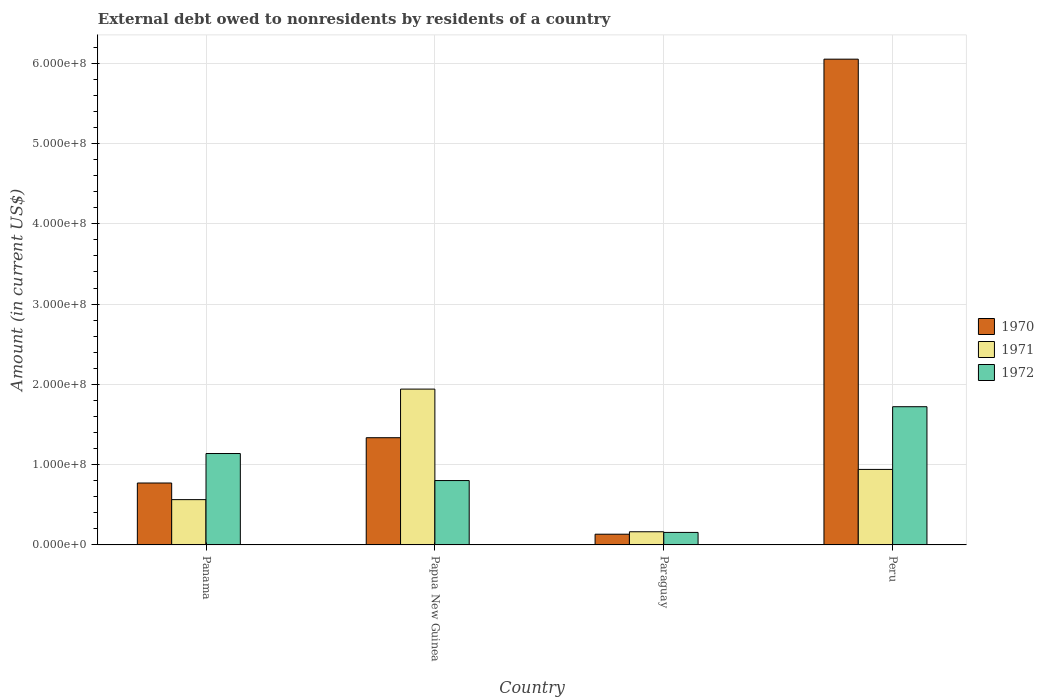How many different coloured bars are there?
Ensure brevity in your answer.  3. Are the number of bars on each tick of the X-axis equal?
Ensure brevity in your answer.  Yes. What is the label of the 4th group of bars from the left?
Make the answer very short. Peru. What is the external debt owed by residents in 1970 in Panama?
Ensure brevity in your answer.  7.71e+07. Across all countries, what is the maximum external debt owed by residents in 1972?
Offer a very short reply. 1.72e+08. Across all countries, what is the minimum external debt owed by residents in 1972?
Offer a terse response. 1.56e+07. In which country was the external debt owed by residents in 1971 minimum?
Your answer should be compact. Paraguay. What is the total external debt owed by residents in 1970 in the graph?
Ensure brevity in your answer.  8.29e+08. What is the difference between the external debt owed by residents in 1970 in Paraguay and that in Peru?
Offer a very short reply. -5.92e+08. What is the difference between the external debt owed by residents in 1970 in Papua New Guinea and the external debt owed by residents in 1971 in Peru?
Give a very brief answer. 3.95e+07. What is the average external debt owed by residents in 1972 per country?
Make the answer very short. 9.54e+07. What is the difference between the external debt owed by residents of/in 1971 and external debt owed by residents of/in 1970 in Papua New Guinea?
Keep it short and to the point. 6.05e+07. In how many countries, is the external debt owed by residents in 1972 greater than 480000000 US$?
Your response must be concise. 0. What is the ratio of the external debt owed by residents in 1971 in Papua New Guinea to that in Peru?
Your response must be concise. 2.06. Is the external debt owed by residents in 1972 in Panama less than that in Papua New Guinea?
Offer a terse response. No. What is the difference between the highest and the second highest external debt owed by residents in 1970?
Provide a short and direct response. 4.71e+08. What is the difference between the highest and the lowest external debt owed by residents in 1970?
Ensure brevity in your answer.  5.92e+08. What does the 3rd bar from the left in Paraguay represents?
Provide a short and direct response. 1972. What does the 2nd bar from the right in Paraguay represents?
Offer a terse response. 1971. How many bars are there?
Your answer should be compact. 12. Are all the bars in the graph horizontal?
Ensure brevity in your answer.  No. How many legend labels are there?
Make the answer very short. 3. What is the title of the graph?
Offer a terse response. External debt owed to nonresidents by residents of a country. Does "1965" appear as one of the legend labels in the graph?
Give a very brief answer. No. What is the label or title of the X-axis?
Keep it short and to the point. Country. What is the Amount (in current US$) of 1970 in Panama?
Provide a short and direct response. 7.71e+07. What is the Amount (in current US$) of 1971 in Panama?
Make the answer very short. 5.64e+07. What is the Amount (in current US$) in 1972 in Panama?
Give a very brief answer. 1.14e+08. What is the Amount (in current US$) in 1970 in Papua New Guinea?
Ensure brevity in your answer.  1.34e+08. What is the Amount (in current US$) of 1971 in Papua New Guinea?
Offer a terse response. 1.94e+08. What is the Amount (in current US$) of 1972 in Papua New Guinea?
Offer a terse response. 8.02e+07. What is the Amount (in current US$) in 1970 in Paraguay?
Your response must be concise. 1.34e+07. What is the Amount (in current US$) of 1971 in Paraguay?
Your answer should be very brief. 1.64e+07. What is the Amount (in current US$) of 1972 in Paraguay?
Offer a very short reply. 1.56e+07. What is the Amount (in current US$) of 1970 in Peru?
Your answer should be compact. 6.05e+08. What is the Amount (in current US$) of 1971 in Peru?
Keep it short and to the point. 9.41e+07. What is the Amount (in current US$) in 1972 in Peru?
Offer a terse response. 1.72e+08. Across all countries, what is the maximum Amount (in current US$) in 1970?
Offer a very short reply. 6.05e+08. Across all countries, what is the maximum Amount (in current US$) of 1971?
Your answer should be compact. 1.94e+08. Across all countries, what is the maximum Amount (in current US$) in 1972?
Offer a very short reply. 1.72e+08. Across all countries, what is the minimum Amount (in current US$) in 1970?
Keep it short and to the point. 1.34e+07. Across all countries, what is the minimum Amount (in current US$) in 1971?
Keep it short and to the point. 1.64e+07. Across all countries, what is the minimum Amount (in current US$) in 1972?
Make the answer very short. 1.56e+07. What is the total Amount (in current US$) in 1970 in the graph?
Give a very brief answer. 8.29e+08. What is the total Amount (in current US$) of 1971 in the graph?
Your answer should be very brief. 3.61e+08. What is the total Amount (in current US$) of 1972 in the graph?
Offer a terse response. 3.82e+08. What is the difference between the Amount (in current US$) of 1970 in Panama and that in Papua New Guinea?
Your answer should be very brief. -5.64e+07. What is the difference between the Amount (in current US$) of 1971 in Panama and that in Papua New Guinea?
Offer a very short reply. -1.38e+08. What is the difference between the Amount (in current US$) of 1972 in Panama and that in Papua New Guinea?
Make the answer very short. 3.37e+07. What is the difference between the Amount (in current US$) in 1970 in Panama and that in Paraguay?
Provide a succinct answer. 6.38e+07. What is the difference between the Amount (in current US$) of 1971 in Panama and that in Paraguay?
Your answer should be very brief. 4.00e+07. What is the difference between the Amount (in current US$) of 1972 in Panama and that in Paraguay?
Your answer should be very brief. 9.83e+07. What is the difference between the Amount (in current US$) in 1970 in Panama and that in Peru?
Provide a succinct answer. -5.28e+08. What is the difference between the Amount (in current US$) of 1971 in Panama and that in Peru?
Give a very brief answer. -3.76e+07. What is the difference between the Amount (in current US$) of 1972 in Panama and that in Peru?
Offer a very short reply. -5.83e+07. What is the difference between the Amount (in current US$) of 1970 in Papua New Guinea and that in Paraguay?
Your answer should be compact. 1.20e+08. What is the difference between the Amount (in current US$) in 1971 in Papua New Guinea and that in Paraguay?
Ensure brevity in your answer.  1.78e+08. What is the difference between the Amount (in current US$) in 1972 in Papua New Guinea and that in Paraguay?
Make the answer very short. 6.46e+07. What is the difference between the Amount (in current US$) of 1970 in Papua New Guinea and that in Peru?
Provide a succinct answer. -4.71e+08. What is the difference between the Amount (in current US$) of 1971 in Papua New Guinea and that in Peru?
Make the answer very short. 1.00e+08. What is the difference between the Amount (in current US$) of 1972 in Papua New Guinea and that in Peru?
Give a very brief answer. -9.20e+07. What is the difference between the Amount (in current US$) in 1970 in Paraguay and that in Peru?
Offer a very short reply. -5.92e+08. What is the difference between the Amount (in current US$) in 1971 in Paraguay and that in Peru?
Your answer should be compact. -7.76e+07. What is the difference between the Amount (in current US$) in 1972 in Paraguay and that in Peru?
Provide a short and direct response. -1.57e+08. What is the difference between the Amount (in current US$) in 1970 in Panama and the Amount (in current US$) in 1971 in Papua New Guinea?
Offer a terse response. -1.17e+08. What is the difference between the Amount (in current US$) in 1970 in Panama and the Amount (in current US$) in 1972 in Papua New Guinea?
Your answer should be compact. -3.07e+06. What is the difference between the Amount (in current US$) in 1971 in Panama and the Amount (in current US$) in 1972 in Papua New Guinea?
Ensure brevity in your answer.  -2.38e+07. What is the difference between the Amount (in current US$) of 1970 in Panama and the Amount (in current US$) of 1971 in Paraguay?
Provide a short and direct response. 6.07e+07. What is the difference between the Amount (in current US$) of 1970 in Panama and the Amount (in current US$) of 1972 in Paraguay?
Keep it short and to the point. 6.15e+07. What is the difference between the Amount (in current US$) of 1971 in Panama and the Amount (in current US$) of 1972 in Paraguay?
Provide a short and direct response. 4.08e+07. What is the difference between the Amount (in current US$) in 1970 in Panama and the Amount (in current US$) in 1971 in Peru?
Offer a terse response. -1.69e+07. What is the difference between the Amount (in current US$) of 1970 in Panama and the Amount (in current US$) of 1972 in Peru?
Give a very brief answer. -9.50e+07. What is the difference between the Amount (in current US$) of 1971 in Panama and the Amount (in current US$) of 1972 in Peru?
Your answer should be compact. -1.16e+08. What is the difference between the Amount (in current US$) of 1970 in Papua New Guinea and the Amount (in current US$) of 1971 in Paraguay?
Give a very brief answer. 1.17e+08. What is the difference between the Amount (in current US$) in 1970 in Papua New Guinea and the Amount (in current US$) in 1972 in Paraguay?
Provide a short and direct response. 1.18e+08. What is the difference between the Amount (in current US$) in 1971 in Papua New Guinea and the Amount (in current US$) in 1972 in Paraguay?
Your response must be concise. 1.78e+08. What is the difference between the Amount (in current US$) in 1970 in Papua New Guinea and the Amount (in current US$) in 1971 in Peru?
Your response must be concise. 3.95e+07. What is the difference between the Amount (in current US$) in 1970 in Papua New Guinea and the Amount (in current US$) in 1972 in Peru?
Keep it short and to the point. -3.86e+07. What is the difference between the Amount (in current US$) in 1971 in Papua New Guinea and the Amount (in current US$) in 1972 in Peru?
Provide a succinct answer. 2.19e+07. What is the difference between the Amount (in current US$) of 1970 in Paraguay and the Amount (in current US$) of 1971 in Peru?
Your answer should be compact. -8.07e+07. What is the difference between the Amount (in current US$) of 1970 in Paraguay and the Amount (in current US$) of 1972 in Peru?
Keep it short and to the point. -1.59e+08. What is the difference between the Amount (in current US$) in 1971 in Paraguay and the Amount (in current US$) in 1972 in Peru?
Ensure brevity in your answer.  -1.56e+08. What is the average Amount (in current US$) of 1970 per country?
Provide a short and direct response. 2.07e+08. What is the average Amount (in current US$) in 1971 per country?
Ensure brevity in your answer.  9.02e+07. What is the average Amount (in current US$) of 1972 per country?
Make the answer very short. 9.54e+07. What is the difference between the Amount (in current US$) in 1970 and Amount (in current US$) in 1971 in Panama?
Keep it short and to the point. 2.07e+07. What is the difference between the Amount (in current US$) in 1970 and Amount (in current US$) in 1972 in Panama?
Provide a succinct answer. -3.67e+07. What is the difference between the Amount (in current US$) in 1971 and Amount (in current US$) in 1972 in Panama?
Ensure brevity in your answer.  -5.74e+07. What is the difference between the Amount (in current US$) of 1970 and Amount (in current US$) of 1971 in Papua New Guinea?
Give a very brief answer. -6.05e+07. What is the difference between the Amount (in current US$) in 1970 and Amount (in current US$) in 1972 in Papua New Guinea?
Keep it short and to the point. 5.34e+07. What is the difference between the Amount (in current US$) in 1971 and Amount (in current US$) in 1972 in Papua New Guinea?
Offer a very short reply. 1.14e+08. What is the difference between the Amount (in current US$) of 1970 and Amount (in current US$) of 1971 in Paraguay?
Offer a terse response. -3.05e+06. What is the difference between the Amount (in current US$) of 1970 and Amount (in current US$) of 1972 in Paraguay?
Provide a short and direct response. -2.23e+06. What is the difference between the Amount (in current US$) in 1971 and Amount (in current US$) in 1972 in Paraguay?
Your answer should be very brief. 8.15e+05. What is the difference between the Amount (in current US$) of 1970 and Amount (in current US$) of 1971 in Peru?
Give a very brief answer. 5.11e+08. What is the difference between the Amount (in current US$) of 1970 and Amount (in current US$) of 1972 in Peru?
Offer a terse response. 4.33e+08. What is the difference between the Amount (in current US$) in 1971 and Amount (in current US$) in 1972 in Peru?
Your answer should be compact. -7.81e+07. What is the ratio of the Amount (in current US$) in 1970 in Panama to that in Papua New Guinea?
Your answer should be very brief. 0.58. What is the ratio of the Amount (in current US$) in 1971 in Panama to that in Papua New Guinea?
Offer a terse response. 0.29. What is the ratio of the Amount (in current US$) in 1972 in Panama to that in Papua New Guinea?
Keep it short and to the point. 1.42. What is the ratio of the Amount (in current US$) of 1970 in Panama to that in Paraguay?
Offer a terse response. 5.77. What is the ratio of the Amount (in current US$) in 1971 in Panama to that in Paraguay?
Provide a succinct answer. 3.44. What is the ratio of the Amount (in current US$) in 1972 in Panama to that in Paraguay?
Give a very brief answer. 7.3. What is the ratio of the Amount (in current US$) in 1970 in Panama to that in Peru?
Provide a short and direct response. 0.13. What is the ratio of the Amount (in current US$) in 1971 in Panama to that in Peru?
Give a very brief answer. 0.6. What is the ratio of the Amount (in current US$) in 1972 in Panama to that in Peru?
Provide a succinct answer. 0.66. What is the ratio of the Amount (in current US$) in 1970 in Papua New Guinea to that in Paraguay?
Your response must be concise. 10. What is the ratio of the Amount (in current US$) of 1971 in Papua New Guinea to that in Paraguay?
Give a very brief answer. 11.83. What is the ratio of the Amount (in current US$) in 1972 in Papua New Guinea to that in Paraguay?
Offer a terse response. 5.14. What is the ratio of the Amount (in current US$) in 1970 in Papua New Guinea to that in Peru?
Give a very brief answer. 0.22. What is the ratio of the Amount (in current US$) of 1971 in Papua New Guinea to that in Peru?
Offer a terse response. 2.06. What is the ratio of the Amount (in current US$) of 1972 in Papua New Guinea to that in Peru?
Keep it short and to the point. 0.47. What is the ratio of the Amount (in current US$) of 1970 in Paraguay to that in Peru?
Your answer should be compact. 0.02. What is the ratio of the Amount (in current US$) of 1971 in Paraguay to that in Peru?
Give a very brief answer. 0.17. What is the ratio of the Amount (in current US$) of 1972 in Paraguay to that in Peru?
Keep it short and to the point. 0.09. What is the difference between the highest and the second highest Amount (in current US$) of 1970?
Offer a very short reply. 4.71e+08. What is the difference between the highest and the second highest Amount (in current US$) of 1971?
Your response must be concise. 1.00e+08. What is the difference between the highest and the second highest Amount (in current US$) of 1972?
Provide a succinct answer. 5.83e+07. What is the difference between the highest and the lowest Amount (in current US$) in 1970?
Your answer should be compact. 5.92e+08. What is the difference between the highest and the lowest Amount (in current US$) in 1971?
Provide a succinct answer. 1.78e+08. What is the difference between the highest and the lowest Amount (in current US$) of 1972?
Your response must be concise. 1.57e+08. 